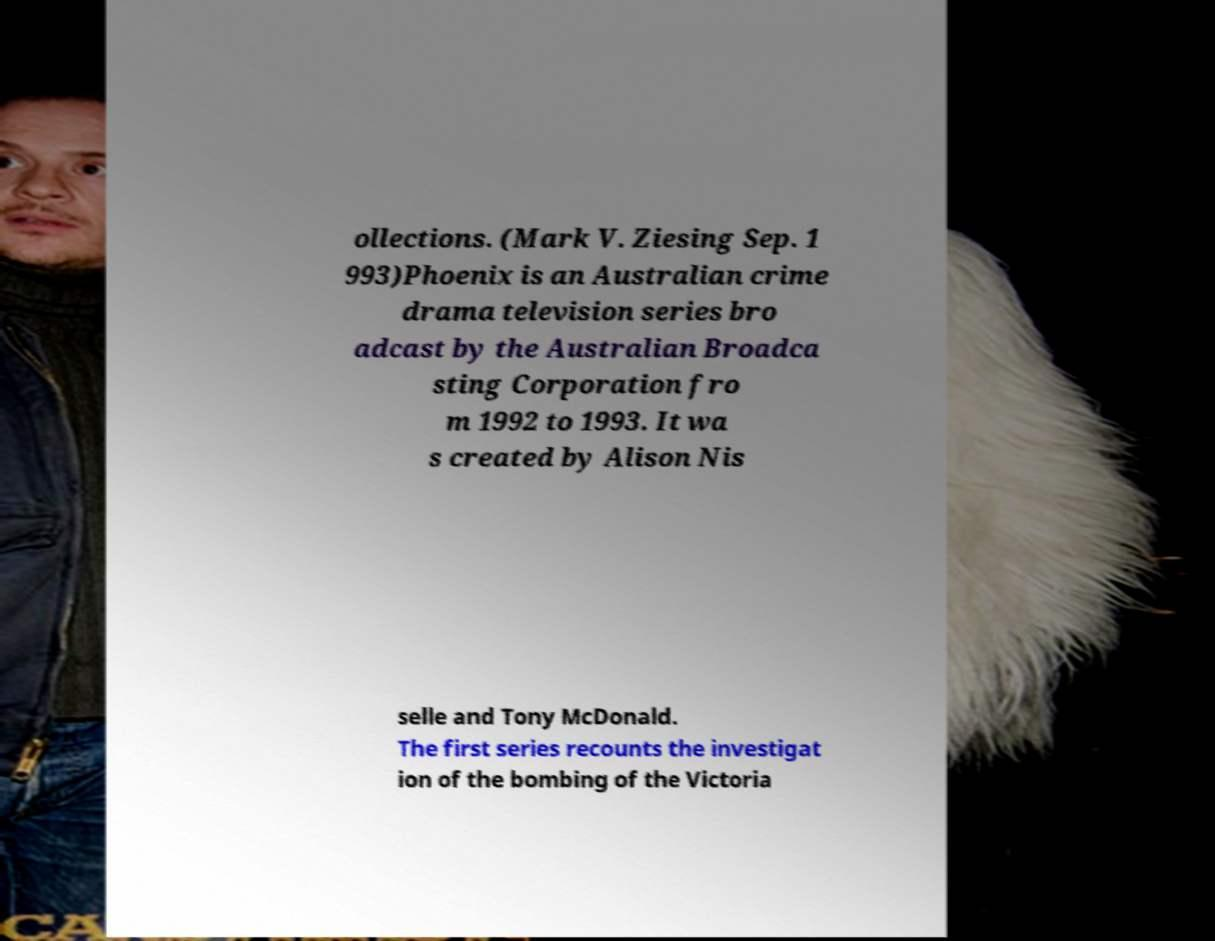Could you assist in decoding the text presented in this image and type it out clearly? ollections. (Mark V. Ziesing Sep. 1 993)Phoenix is an Australian crime drama television series bro adcast by the Australian Broadca sting Corporation fro m 1992 to 1993. It wa s created by Alison Nis selle and Tony McDonald. The first series recounts the investigat ion of the bombing of the Victoria 